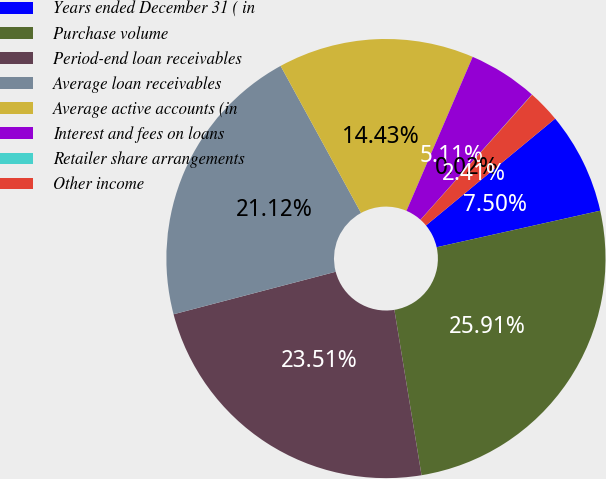Convert chart to OTSL. <chart><loc_0><loc_0><loc_500><loc_500><pie_chart><fcel>Years ended December 31 ( in<fcel>Purchase volume<fcel>Period-end loan receivables<fcel>Average loan receivables<fcel>Average active accounts (in<fcel>Interest and fees on loans<fcel>Retailer share arrangements<fcel>Other income<nl><fcel>7.5%<fcel>25.91%<fcel>23.51%<fcel>21.12%<fcel>14.43%<fcel>5.11%<fcel>0.02%<fcel>2.41%<nl></chart> 